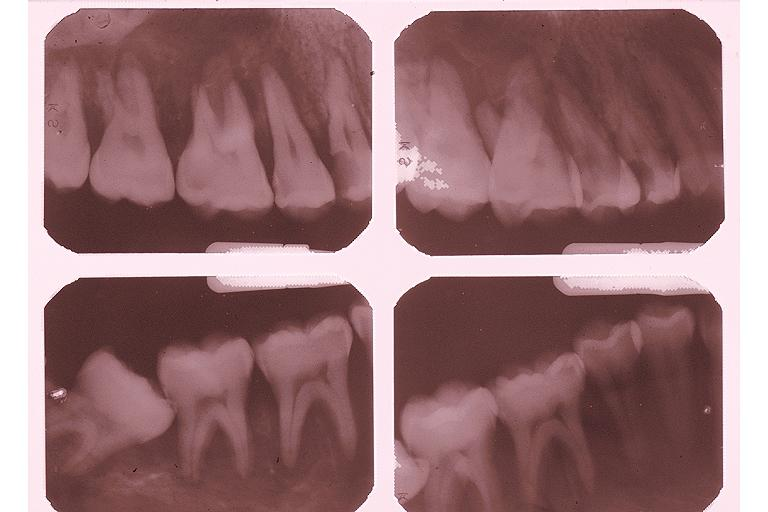does this image show burkits lymphoma?
Answer the question using a single word or phrase. Yes 